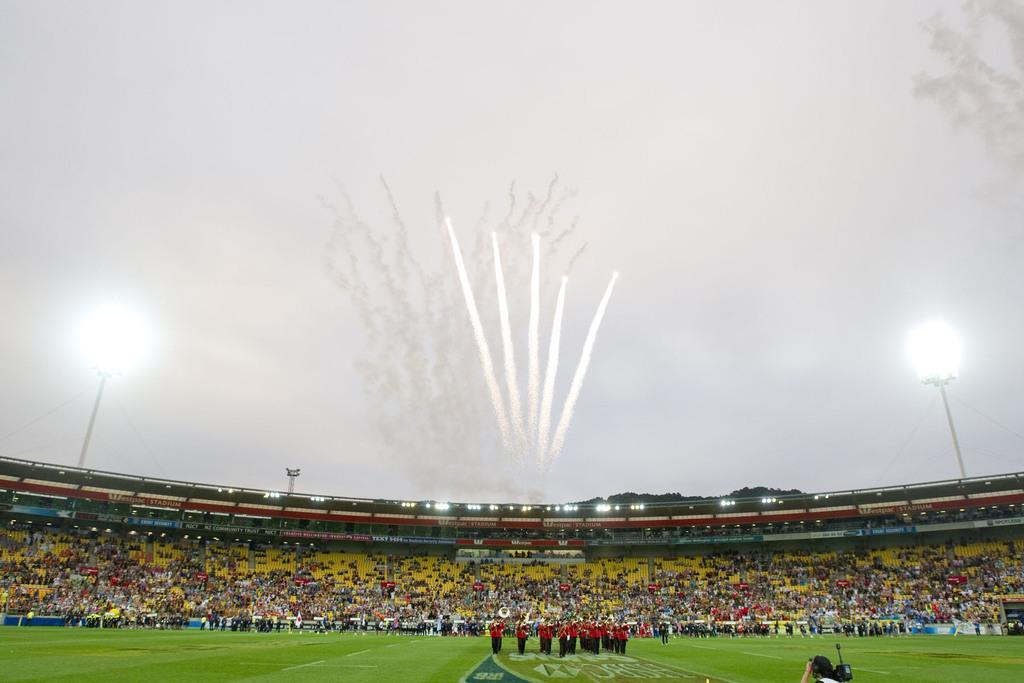Could you give a brief overview of what you see in this image? People are present in a stadium. There are lights and fireworks in the sky. 